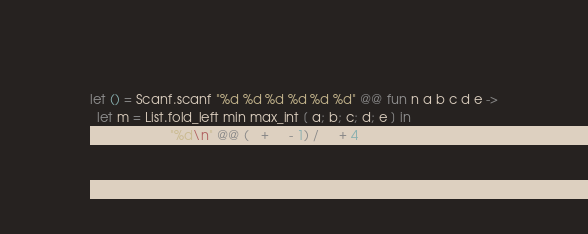<code> <loc_0><loc_0><loc_500><loc_500><_OCaml_>let () = Scanf.scanf "%d %d %d %d %d %d" @@ fun n a b c d e ->
  let m = List.fold_left min max_int [ a; b; c; d; e ] in
  Printf.printf "%d\n" @@ (n + m - 1) / m + 4
</code> 